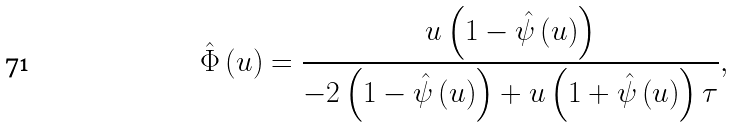Convert formula to latex. <formula><loc_0><loc_0><loc_500><loc_500>\hat { \Phi } \left ( u \right ) = \frac { u \left ( 1 - \hat { \psi } \left ( u \right ) \right ) } { - 2 \left ( 1 - \hat { \psi } \left ( u \right ) \right ) + u \left ( 1 + \hat { \psi } \left ( u \right ) \right ) \tau } ,</formula> 